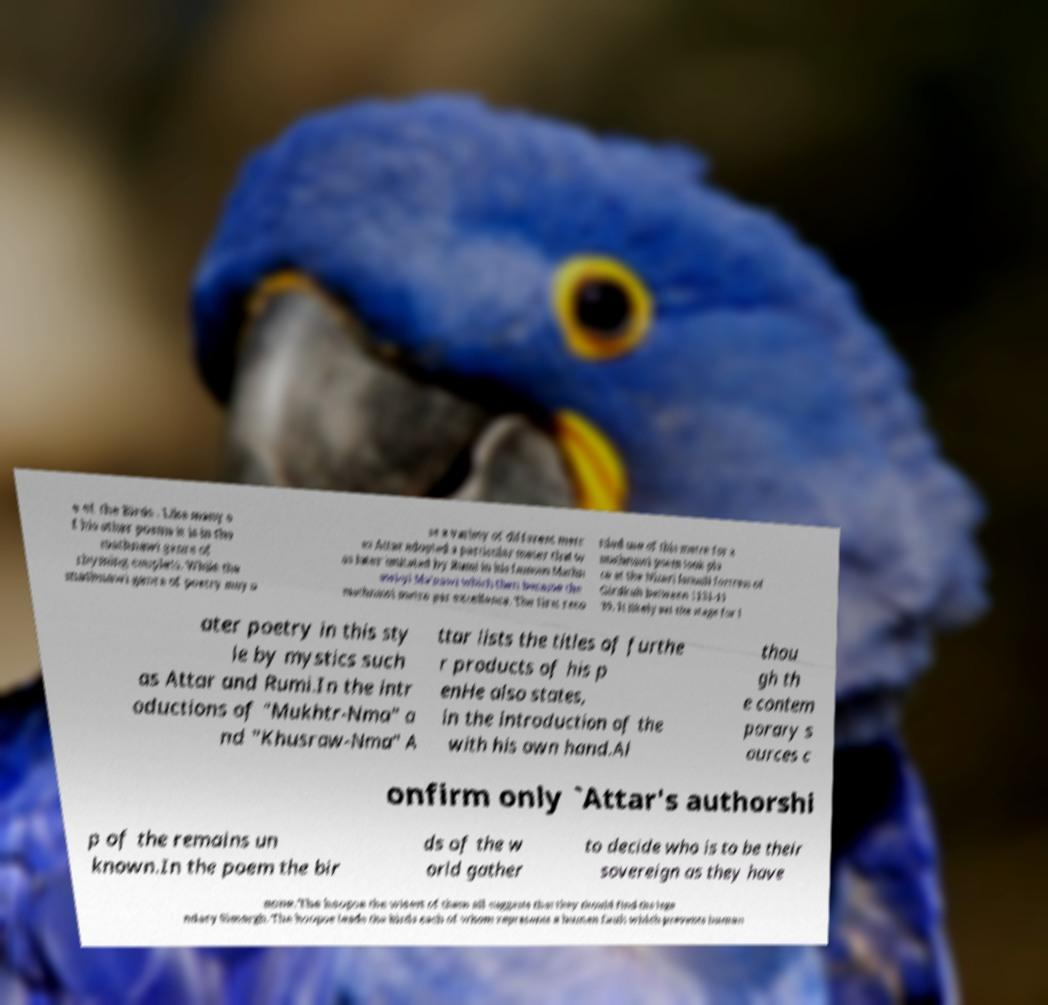Can you accurately transcribe the text from the provided image for me? e of the Birds . Like many o f his other poems it is in the mathnawi genre of rhyming couplets. While the mathnawi genre of poetry may u se a variety of different metr es Attar adopted a particular meter that w as later imitated by Rumi in his famous Mathn awi-yi Ma’nawi which then became the mathnawi metre par excellence. The first reco rded use of this metre for a mathnawi poem took pla ce at the Nizari Ismaili fortress of Girdkuh between 1131-11 39. It likely set the stage for l ater poetry in this sty le by mystics such as Attar and Rumi.In the intr oductions of "Mukhtr-Nma" a nd "Khusraw-Nma" A ttar lists the titles of furthe r products of his p enHe also states, in the introduction of the with his own hand.Al thou gh th e contem porary s ources c onfirm only `Attar's authorshi p of the remains un known.In the poem the bir ds of the w orld gather to decide who is to be their sovereign as they have none. The hoopoe the wisest of them all suggests that they should find the lege ndary Simorgh. The hoopoe leads the birds each of whom represents a human fault which prevents human 